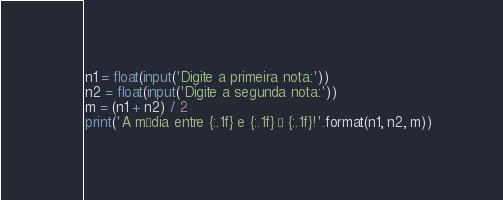Convert code to text. <code><loc_0><loc_0><loc_500><loc_500><_Python_>n1 = float(input('Digite a primeira nota:'))
n2 = float(input('Digite a segunda nota:'))
m = (n1 + n2) / 2 
print('A média entre {:.1f} e {:.1f} é {:.1f}!'.format(n1, n2, m))
</code> 